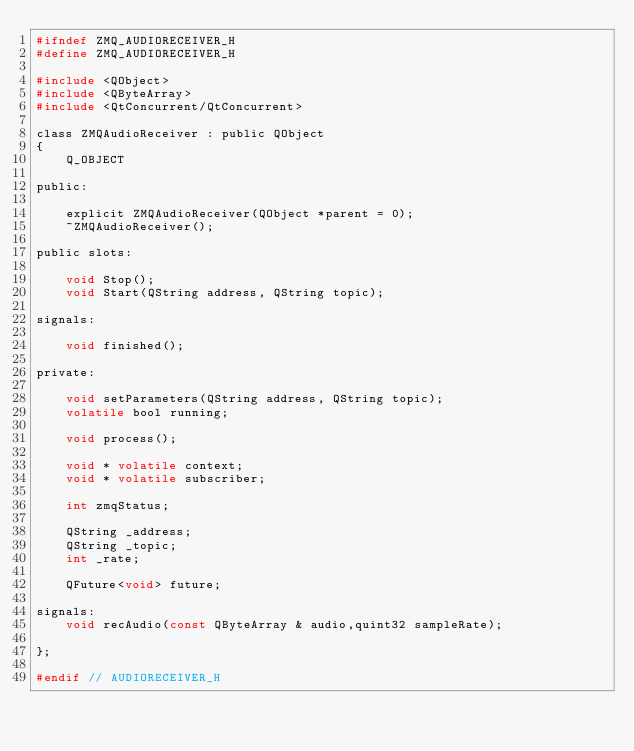<code> <loc_0><loc_0><loc_500><loc_500><_C_>#ifndef ZMQ_AUDIORECEIVER_H
#define ZMQ_AUDIORECEIVER_H

#include <QObject>
#include <QByteArray>
#include <QtConcurrent/QtConcurrent>

class ZMQAudioReceiver : public QObject
{
    Q_OBJECT

public:

    explicit ZMQAudioReceiver(QObject *parent = 0);
    ~ZMQAudioReceiver();

public slots:

    void Stop();
    void Start(QString address, QString topic);

signals:

    void finished();

private:

    void setParameters(QString address, QString topic);
    volatile bool running;

    void process();

    void * volatile context;
    void * volatile subscriber;

    int zmqStatus;

    QString _address;
    QString _topic;
    int _rate;

    QFuture<void> future;

signals:
    void recAudio(const QByteArray & audio,quint32 sampleRate);

};

#endif // AUDIORECEIVER_H
</code> 